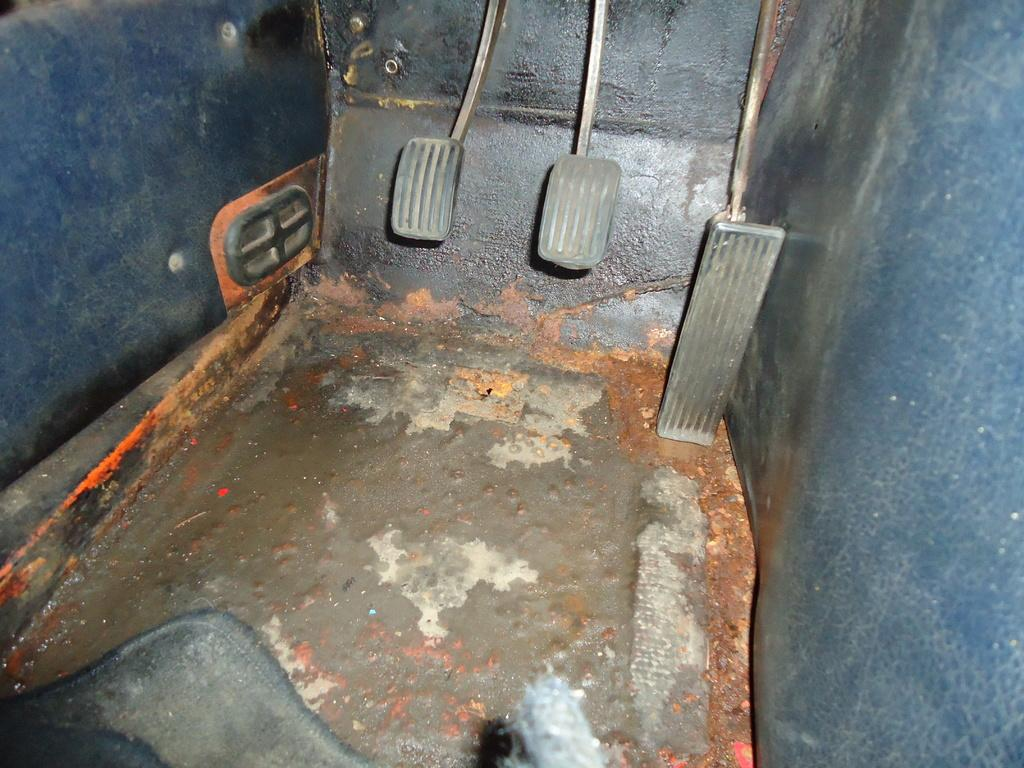What type of vehicle is shown in the image? The image shows an inside view of a vehicle. What can be seen on the floor of the vehicle? There are pedals visible in the image. What type of plane is visible in the image? There is no plane present in the image; it shows an inside view of a vehicle. Is there any indication of a business transaction taking place in the image? There is no indication of a business transaction taking place in the image. 